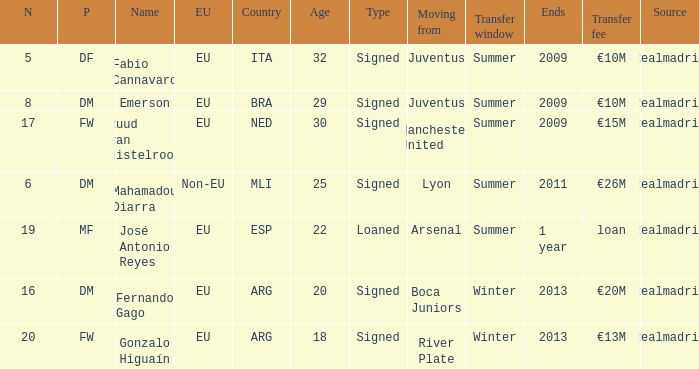What is the type of the player whose transfer fee was €20m? Signed. 